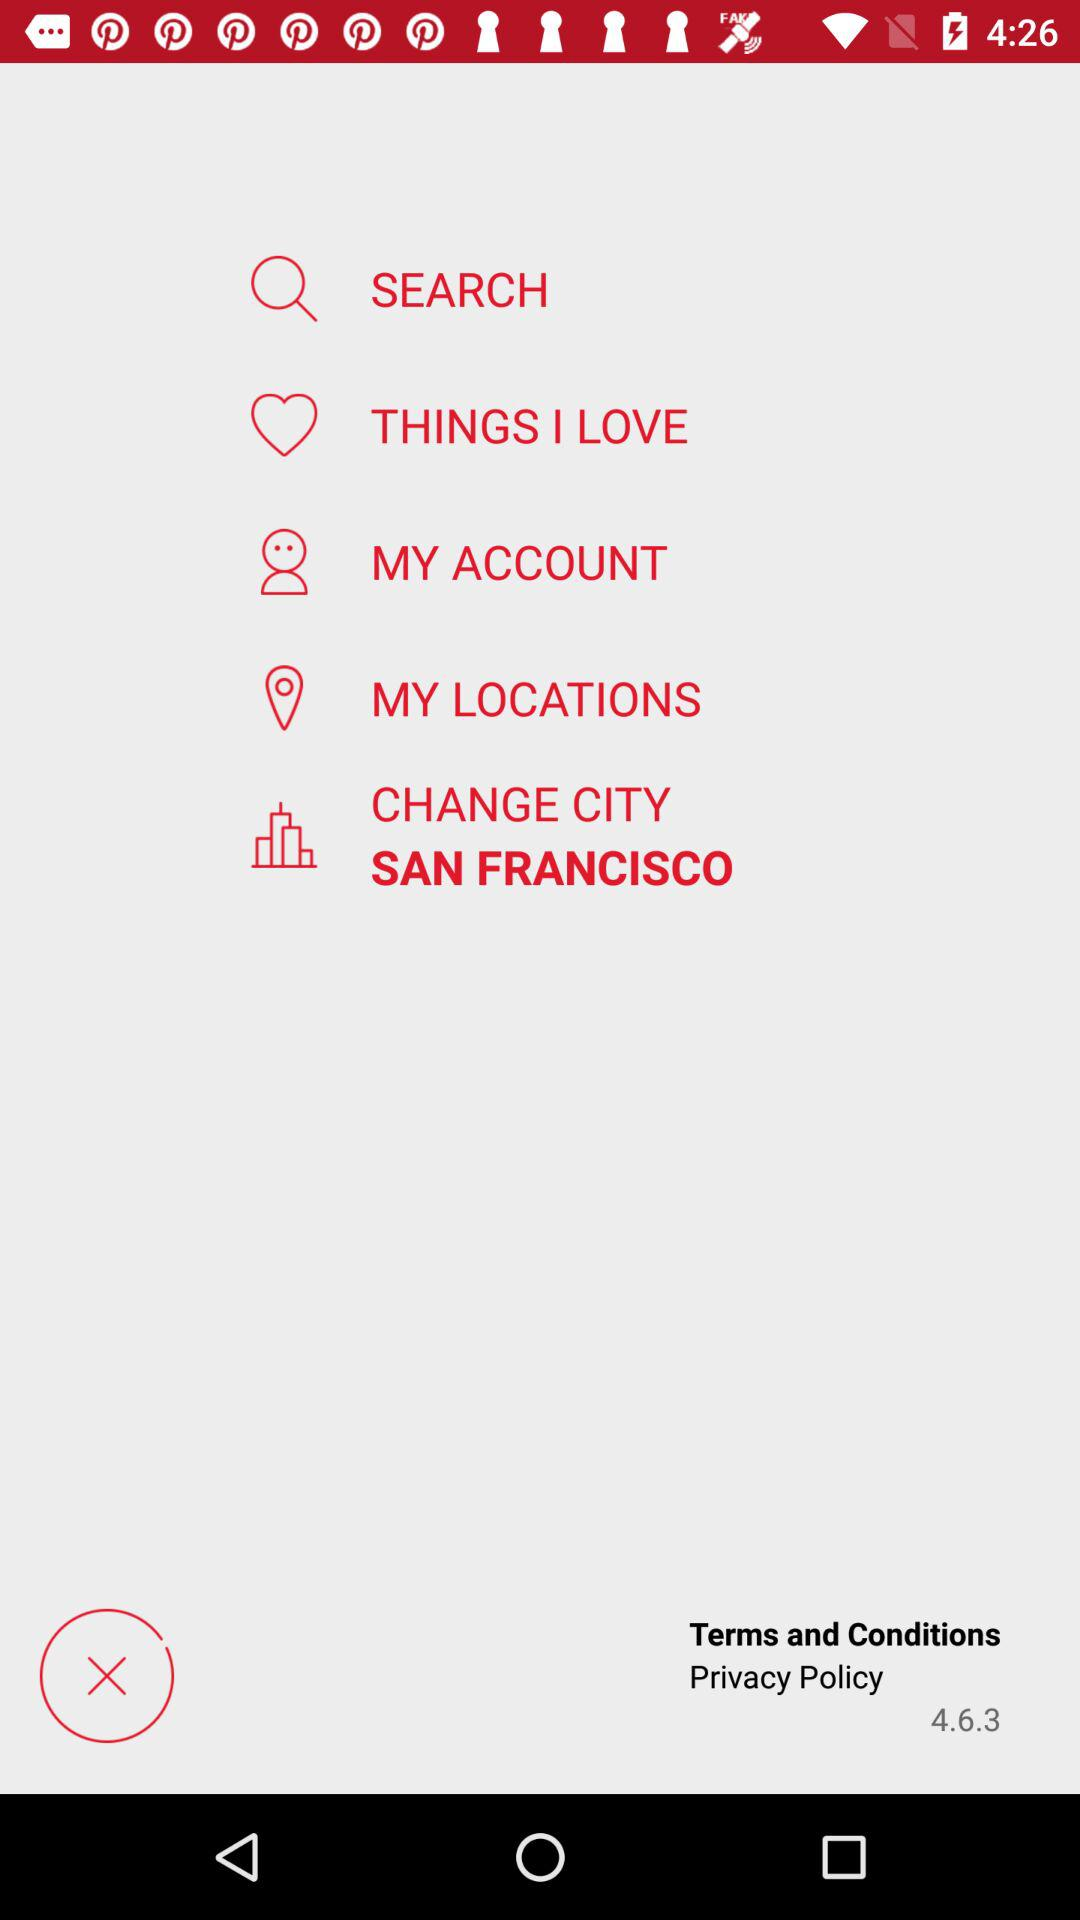What is the language of Bristol? The language is English. 